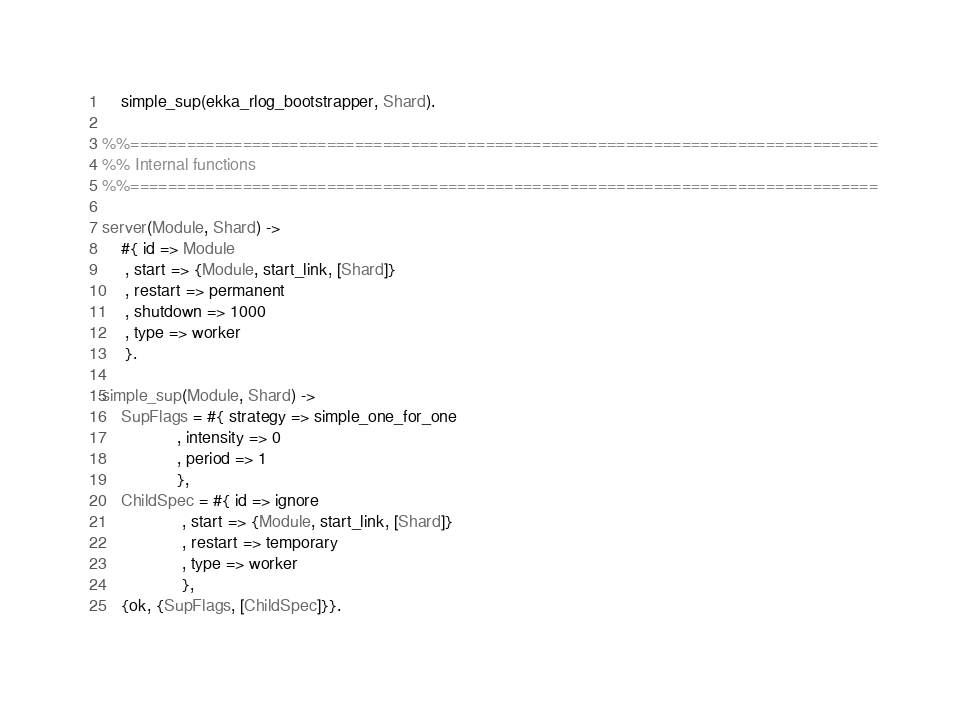<code> <loc_0><loc_0><loc_500><loc_500><_Erlang_>    simple_sup(ekka_rlog_bootstrapper, Shard).

%%================================================================================
%% Internal functions
%%================================================================================

server(Module, Shard) ->
    #{ id => Module
     , start => {Module, start_link, [Shard]}
     , restart => permanent
     , shutdown => 1000
     , type => worker
     }.

simple_sup(Module, Shard) ->
    SupFlags = #{ strategy => simple_one_for_one
                , intensity => 0
                , period => 1
                },
    ChildSpec = #{ id => ignore
                 , start => {Module, start_link, [Shard]}
                 , restart => temporary
                 , type => worker
                 },
    {ok, {SupFlags, [ChildSpec]}}.
</code> 